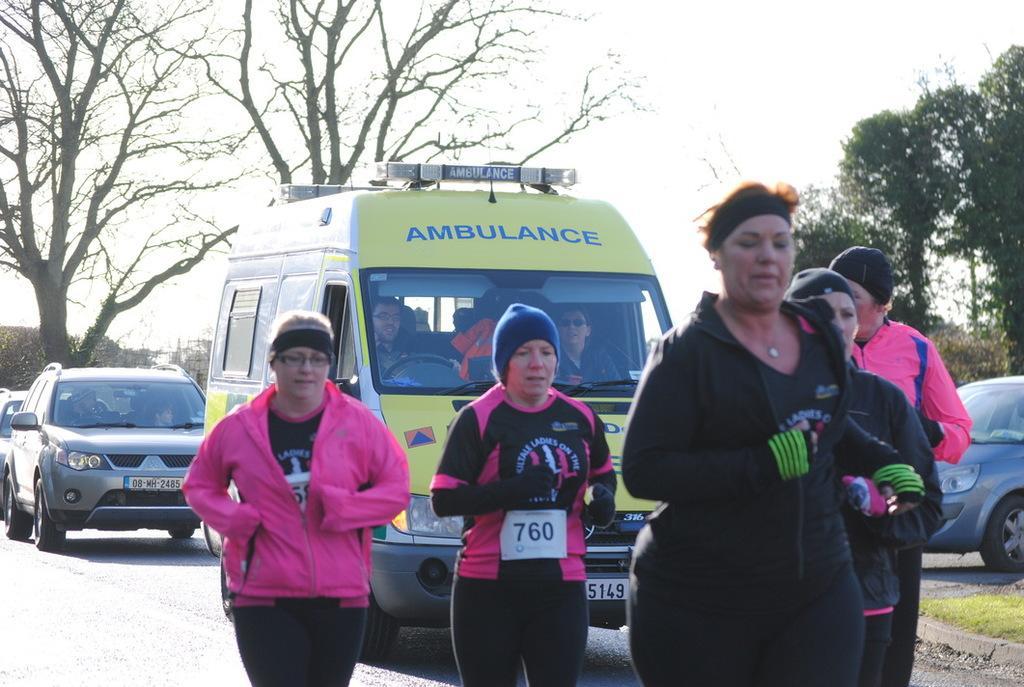Describe this image in one or two sentences. In this image i can see few women running on the road. In the background i can see a ambulance , few cars, few trees and the sky. 